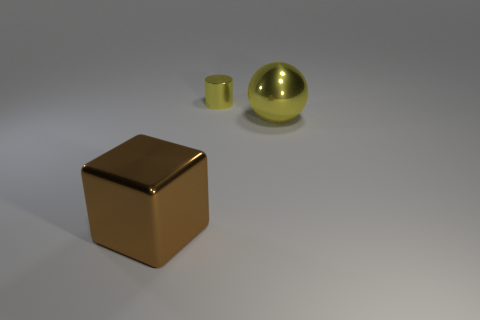Add 3 cylinders. How many objects exist? 6 Subtract all spheres. How many objects are left? 2 Add 1 yellow spheres. How many yellow spheres exist? 2 Subtract 0 blue cylinders. How many objects are left? 3 Subtract all tiny cylinders. Subtract all brown cubes. How many objects are left? 1 Add 1 big shiny cubes. How many big shiny cubes are left? 2 